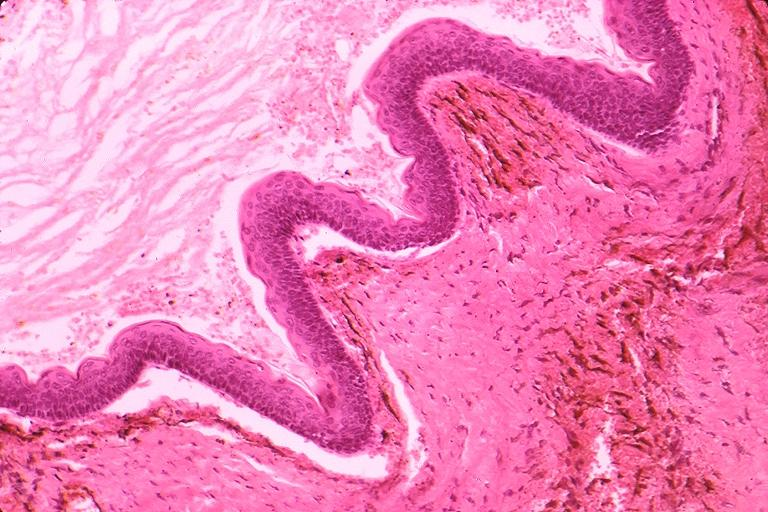where is this?
Answer the question using a single word or phrase. Oral 